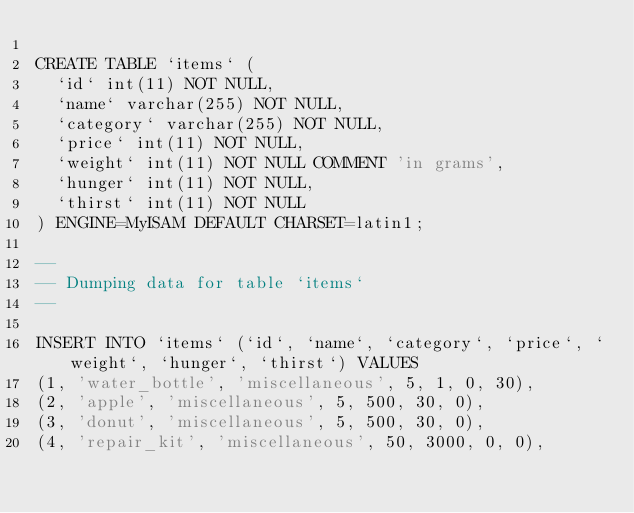<code> <loc_0><loc_0><loc_500><loc_500><_SQL_>
CREATE TABLE `items` (
  `id` int(11) NOT NULL,
  `name` varchar(255) NOT NULL,
  `category` varchar(255) NOT NULL,
  `price` int(11) NOT NULL,
  `weight` int(11) NOT NULL COMMENT 'in grams',
  `hunger` int(11) NOT NULL,
  `thirst` int(11) NOT NULL
) ENGINE=MyISAM DEFAULT CHARSET=latin1;

--
-- Dumping data for table `items`
--

INSERT INTO `items` (`id`, `name`, `category`, `price`, `weight`, `hunger`, `thirst`) VALUES
(1, 'water_bottle', 'miscellaneous', 5, 1, 0, 30),
(2, 'apple', 'miscellaneous', 5, 500, 30, 0),
(3, 'donut', 'miscellaneous', 5, 500, 30, 0),
(4, 'repair_kit', 'miscellaneous', 50, 3000, 0, 0),</code> 